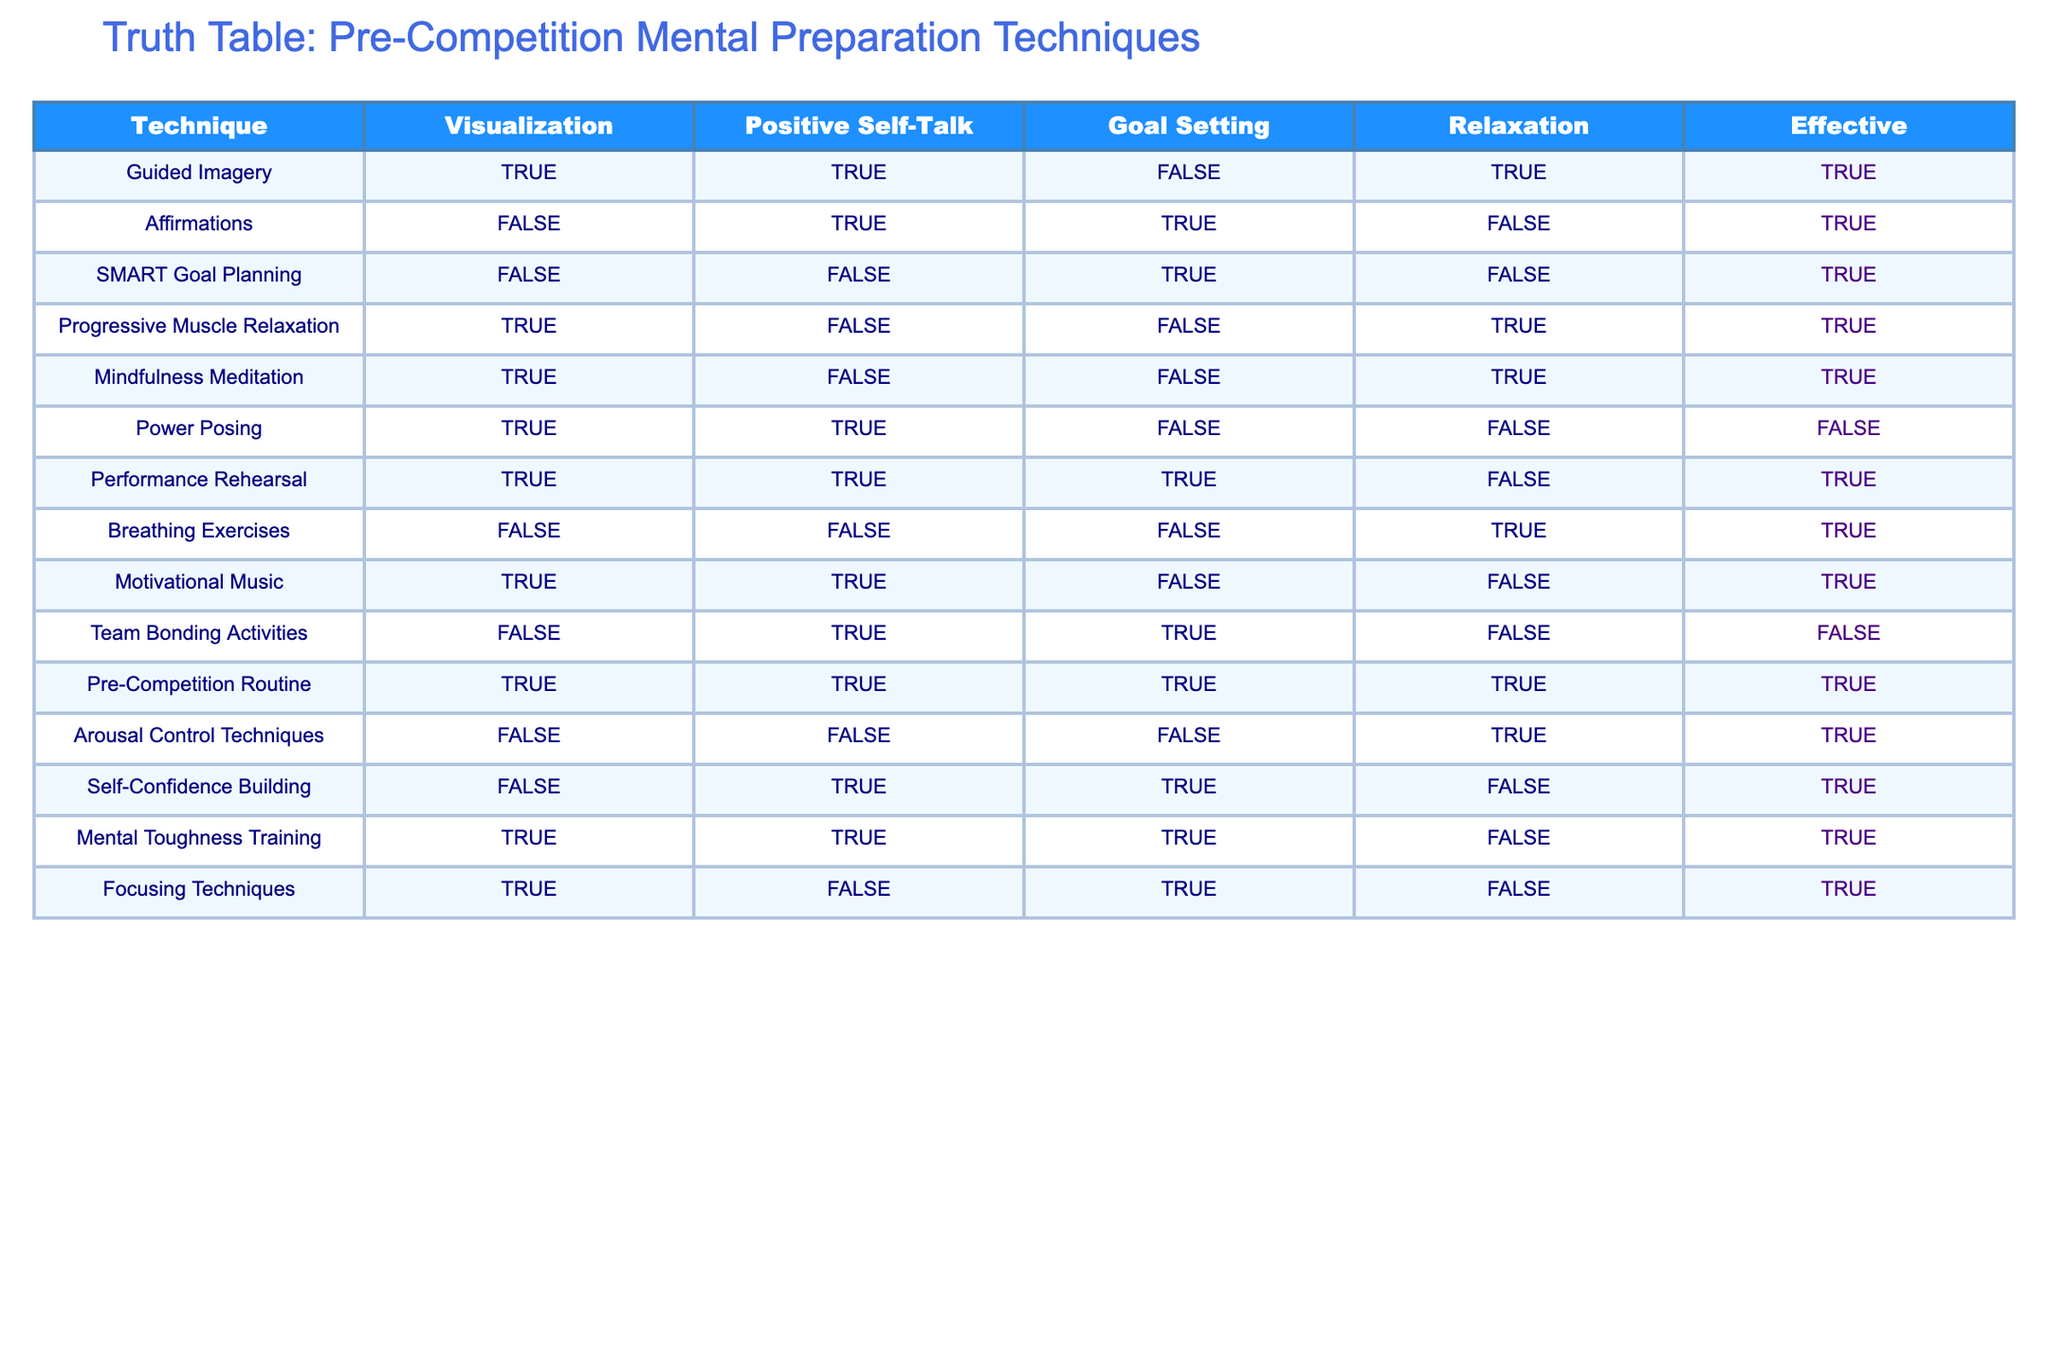What percentage of techniques are deemed effective? There are 14 total techniques listed in the table. From the "Effective" column, 9 techniques are marked as TRUE. To find the percentage, we calculate (9/14) * 100 = 64.29%.
Answer: 64.29% How many techniques involve Visualization but are not Effective? In the "Visualization" column, we find techniques that are marked TRUE and check the "Effective" column for their corresponding values. Guided Imagery, Power Posing, and Pre-Competition Routine are TRUE under Visualization. However, Power Posing is the only one that is not effective (FALSE). Therefore, there is 1 technique that meets these criteria.
Answer: 1 Is Progressive Muscle Relaxation considered effective? Looking at the "Effective" column corresponding to Progressive Muscle Relaxation, it shows TRUE, indicating that it is effective.
Answer: Yes Which technique has the most positive self-talk and is also effective? We examine the "Positive Self-Talk" column to identify techniques marked TRUE that are also effective. The techniques with TRUE in Positive Self-Talk are Guided Imagery, Affirmations, Performance Rehearsal, and Self-Confidence Building. Each of these is then checked against the "Effective" column. Guided Imagery, Affirmations, and Performance Rehearsal are effective, but Performance Rehearsal notably has additional techniques (Goal Setting) marked TRUE, resulting in it having the most positive self-talk markings while still being effective.
Answer: Performance Rehearsal How many techniques utilize Relaxation techniques and are effective? The "Relaxation" column marks techniques as TRUE for Progressive Muscle Relaxation, Mindfulness Meditation, Breathing Exercises, and Arousal Control Techniques. Out of these, Progressive Muscle Relaxation, Mindfulness Meditation, and Breathing Exercises are marked as Effective, resulting in 3 techniques used for Relaxation and deemed effective.
Answer: 3 Are there any techniques that use Goal Setting but are not effective? In the "Goal Setting" column, we look for techniques that are marked TRUE and then check the corresponding "Effective" column. Affirmations and Team Bonding Activities are both marked TRUE for Goal Setting. Out of these, Team Bonding Activities is marked FALSE in the Effective column, indicating that it is not effective. So, there is 1 technique that fits this criteria.
Answer: 1 What is the total number of techniques that incorporate both Visualization and Goal Setting? In the "Visualization" column, we look for techniques marked TRUE and then check their "Goal Setting" column. Guided Imagery, Power Posing, and Performance Rehearsal are marked TRUE in Visualization. However, only Guided Imagery and Performance Rehearsal are also marked TRUE in Goal Setting. Thus, there are 2 techniques that meet these criteria.
Answer: 2 Which technique is effective and employs both Positive Self-Talk and Relaxation? Checking the "Positive Self-Talk" and "Relaxation" columns, we find techniques marked TRUE. The candidates are Guided Imagery and Breathing Exercises; both are also marked TRUE in the Effective column. However, only Breathing Exercises employs both techniques for effective results.
Answer: Breathing Exercises 